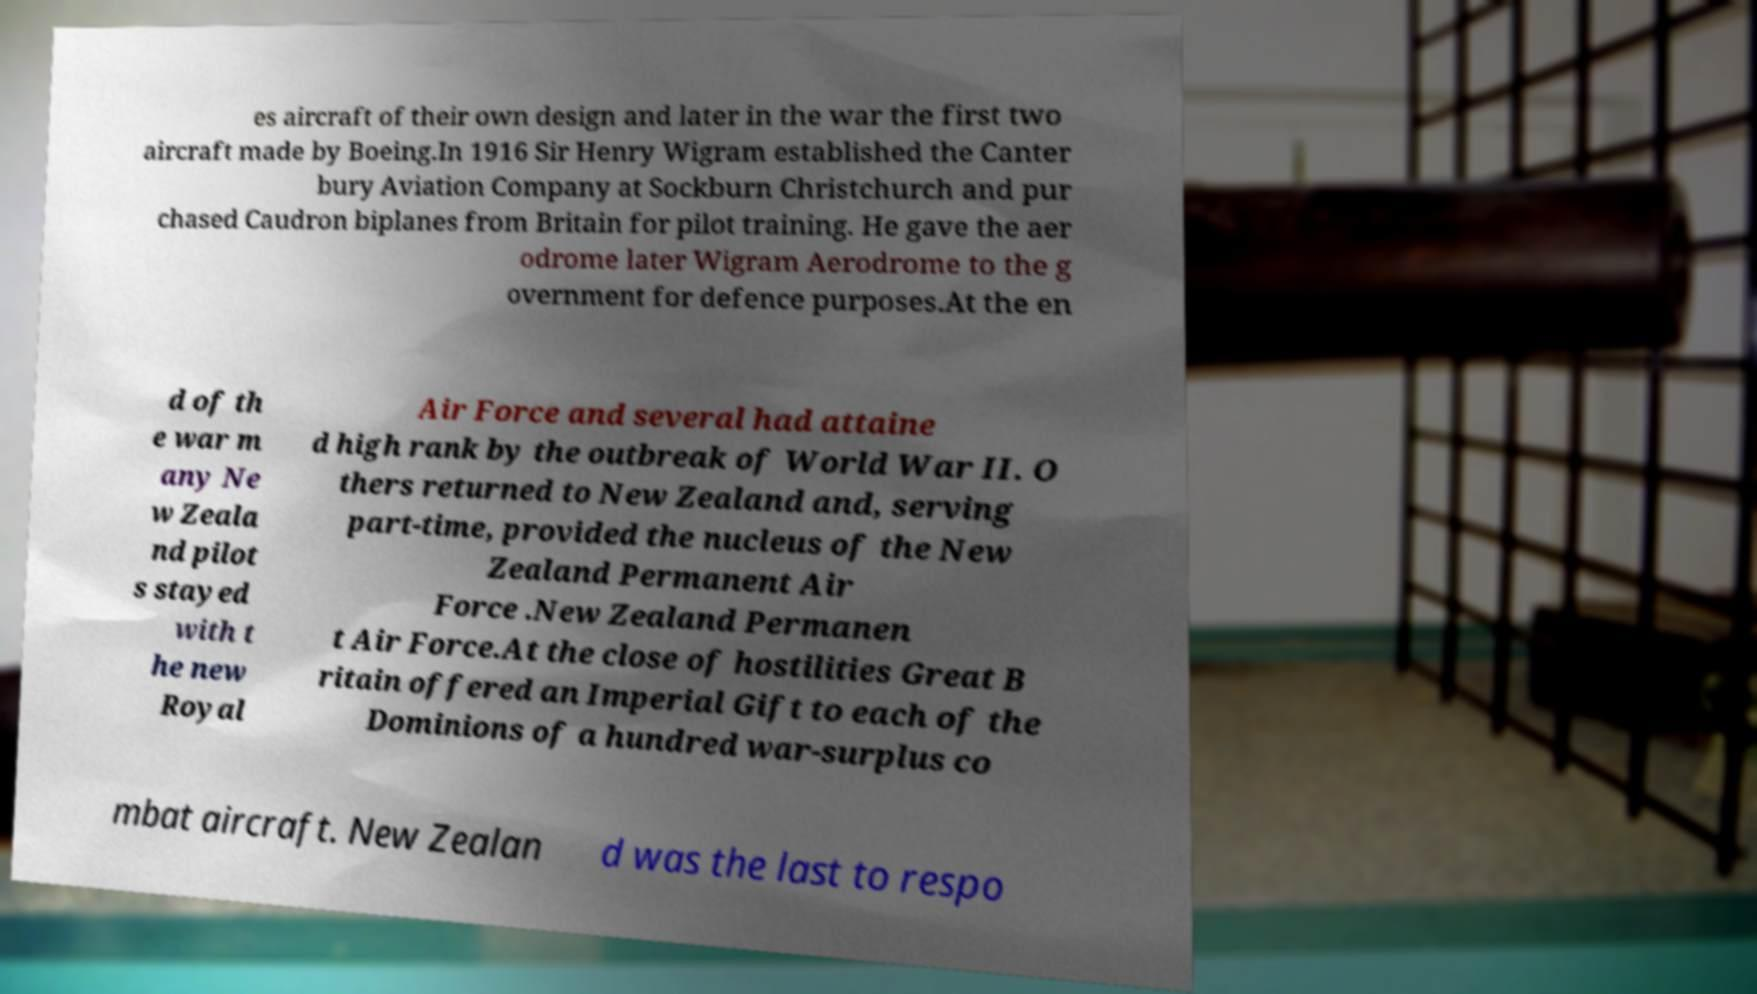Can you accurately transcribe the text from the provided image for me? es aircraft of their own design and later in the war the first two aircraft made by Boeing.In 1916 Sir Henry Wigram established the Canter bury Aviation Company at Sockburn Christchurch and pur chased Caudron biplanes from Britain for pilot training. He gave the aer odrome later Wigram Aerodrome to the g overnment for defence purposes.At the en d of th e war m any Ne w Zeala nd pilot s stayed with t he new Royal Air Force and several had attaine d high rank by the outbreak of World War II. O thers returned to New Zealand and, serving part-time, provided the nucleus of the New Zealand Permanent Air Force .New Zealand Permanen t Air Force.At the close of hostilities Great B ritain offered an Imperial Gift to each of the Dominions of a hundred war-surplus co mbat aircraft. New Zealan d was the last to respo 